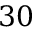Convert formula to latex. <formula><loc_0><loc_0><loc_500><loc_500>3 0</formula> 